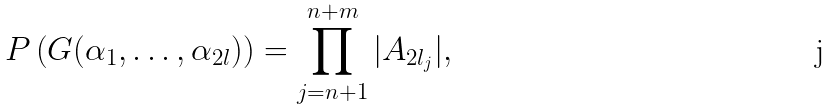<formula> <loc_0><loc_0><loc_500><loc_500>P \left ( G ( \alpha _ { 1 } , \dots , \alpha _ { 2 l } ) \right ) = \prod _ { j = n + 1 } ^ { n + m } | A _ { 2 l _ { j } } | ,</formula> 